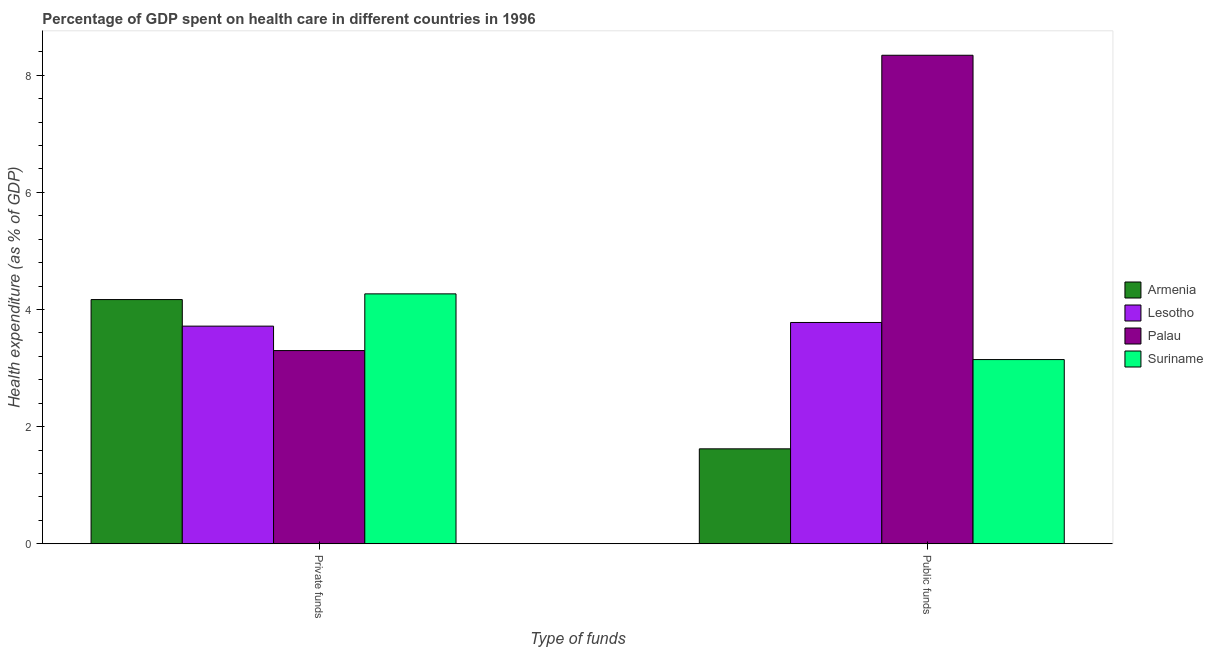How many different coloured bars are there?
Your answer should be compact. 4. How many bars are there on the 1st tick from the right?
Offer a very short reply. 4. What is the label of the 1st group of bars from the left?
Give a very brief answer. Private funds. What is the amount of private funds spent in healthcare in Suriname?
Provide a short and direct response. 4.27. Across all countries, what is the maximum amount of public funds spent in healthcare?
Give a very brief answer. 8.34. Across all countries, what is the minimum amount of private funds spent in healthcare?
Provide a succinct answer. 3.3. In which country was the amount of private funds spent in healthcare maximum?
Offer a very short reply. Suriname. In which country was the amount of public funds spent in healthcare minimum?
Make the answer very short. Armenia. What is the total amount of public funds spent in healthcare in the graph?
Your response must be concise. 16.89. What is the difference between the amount of private funds spent in healthcare in Lesotho and that in Armenia?
Provide a succinct answer. -0.45. What is the difference between the amount of public funds spent in healthcare in Suriname and the amount of private funds spent in healthcare in Lesotho?
Provide a succinct answer. -0.57. What is the average amount of private funds spent in healthcare per country?
Provide a short and direct response. 3.86. What is the difference between the amount of private funds spent in healthcare and amount of public funds spent in healthcare in Armenia?
Your response must be concise. 2.55. What is the ratio of the amount of private funds spent in healthcare in Lesotho to that in Palau?
Offer a very short reply. 1.13. Is the amount of private funds spent in healthcare in Armenia less than that in Suriname?
Offer a very short reply. Yes. What does the 4th bar from the left in Public funds represents?
Provide a short and direct response. Suriname. What does the 3rd bar from the right in Private funds represents?
Ensure brevity in your answer.  Lesotho. What is the difference between two consecutive major ticks on the Y-axis?
Give a very brief answer. 2. Does the graph contain grids?
Your response must be concise. No. Where does the legend appear in the graph?
Make the answer very short. Center right. How many legend labels are there?
Make the answer very short. 4. What is the title of the graph?
Provide a succinct answer. Percentage of GDP spent on health care in different countries in 1996. Does "Kuwait" appear as one of the legend labels in the graph?
Give a very brief answer. No. What is the label or title of the X-axis?
Offer a terse response. Type of funds. What is the label or title of the Y-axis?
Offer a terse response. Health expenditure (as % of GDP). What is the Health expenditure (as % of GDP) of Armenia in Private funds?
Ensure brevity in your answer.  4.17. What is the Health expenditure (as % of GDP) in Lesotho in Private funds?
Your answer should be very brief. 3.72. What is the Health expenditure (as % of GDP) in Palau in Private funds?
Provide a succinct answer. 3.3. What is the Health expenditure (as % of GDP) in Suriname in Private funds?
Your answer should be compact. 4.27. What is the Health expenditure (as % of GDP) in Armenia in Public funds?
Ensure brevity in your answer.  1.62. What is the Health expenditure (as % of GDP) in Lesotho in Public funds?
Ensure brevity in your answer.  3.78. What is the Health expenditure (as % of GDP) in Palau in Public funds?
Give a very brief answer. 8.34. What is the Health expenditure (as % of GDP) in Suriname in Public funds?
Ensure brevity in your answer.  3.15. Across all Type of funds, what is the maximum Health expenditure (as % of GDP) in Armenia?
Your answer should be compact. 4.17. Across all Type of funds, what is the maximum Health expenditure (as % of GDP) of Lesotho?
Keep it short and to the point. 3.78. Across all Type of funds, what is the maximum Health expenditure (as % of GDP) in Palau?
Offer a terse response. 8.34. Across all Type of funds, what is the maximum Health expenditure (as % of GDP) in Suriname?
Offer a terse response. 4.27. Across all Type of funds, what is the minimum Health expenditure (as % of GDP) of Armenia?
Make the answer very short. 1.62. Across all Type of funds, what is the minimum Health expenditure (as % of GDP) of Lesotho?
Provide a short and direct response. 3.72. Across all Type of funds, what is the minimum Health expenditure (as % of GDP) of Palau?
Provide a short and direct response. 3.3. Across all Type of funds, what is the minimum Health expenditure (as % of GDP) in Suriname?
Make the answer very short. 3.15. What is the total Health expenditure (as % of GDP) of Armenia in the graph?
Your answer should be compact. 5.79. What is the total Health expenditure (as % of GDP) of Lesotho in the graph?
Provide a succinct answer. 7.49. What is the total Health expenditure (as % of GDP) in Palau in the graph?
Ensure brevity in your answer.  11.64. What is the total Health expenditure (as % of GDP) in Suriname in the graph?
Provide a short and direct response. 7.41. What is the difference between the Health expenditure (as % of GDP) in Armenia in Private funds and that in Public funds?
Ensure brevity in your answer.  2.55. What is the difference between the Health expenditure (as % of GDP) of Lesotho in Private funds and that in Public funds?
Offer a terse response. -0.06. What is the difference between the Health expenditure (as % of GDP) of Palau in Private funds and that in Public funds?
Offer a very short reply. -5.04. What is the difference between the Health expenditure (as % of GDP) in Suriname in Private funds and that in Public funds?
Make the answer very short. 1.12. What is the difference between the Health expenditure (as % of GDP) of Armenia in Private funds and the Health expenditure (as % of GDP) of Lesotho in Public funds?
Provide a short and direct response. 0.39. What is the difference between the Health expenditure (as % of GDP) of Armenia in Private funds and the Health expenditure (as % of GDP) of Palau in Public funds?
Your answer should be very brief. -4.17. What is the difference between the Health expenditure (as % of GDP) of Armenia in Private funds and the Health expenditure (as % of GDP) of Suriname in Public funds?
Your answer should be very brief. 1.02. What is the difference between the Health expenditure (as % of GDP) in Lesotho in Private funds and the Health expenditure (as % of GDP) in Palau in Public funds?
Your answer should be very brief. -4.62. What is the difference between the Health expenditure (as % of GDP) of Lesotho in Private funds and the Health expenditure (as % of GDP) of Suriname in Public funds?
Provide a short and direct response. 0.57. What is the difference between the Health expenditure (as % of GDP) in Palau in Private funds and the Health expenditure (as % of GDP) in Suriname in Public funds?
Make the answer very short. 0.15. What is the average Health expenditure (as % of GDP) in Armenia per Type of funds?
Keep it short and to the point. 2.9. What is the average Health expenditure (as % of GDP) in Lesotho per Type of funds?
Offer a very short reply. 3.75. What is the average Health expenditure (as % of GDP) of Palau per Type of funds?
Give a very brief answer. 5.82. What is the average Health expenditure (as % of GDP) of Suriname per Type of funds?
Provide a succinct answer. 3.71. What is the difference between the Health expenditure (as % of GDP) in Armenia and Health expenditure (as % of GDP) in Lesotho in Private funds?
Ensure brevity in your answer.  0.45. What is the difference between the Health expenditure (as % of GDP) in Armenia and Health expenditure (as % of GDP) in Palau in Private funds?
Offer a terse response. 0.87. What is the difference between the Health expenditure (as % of GDP) of Armenia and Health expenditure (as % of GDP) of Suriname in Private funds?
Make the answer very short. -0.1. What is the difference between the Health expenditure (as % of GDP) in Lesotho and Health expenditure (as % of GDP) in Palau in Private funds?
Ensure brevity in your answer.  0.42. What is the difference between the Health expenditure (as % of GDP) of Lesotho and Health expenditure (as % of GDP) of Suriname in Private funds?
Offer a terse response. -0.55. What is the difference between the Health expenditure (as % of GDP) in Palau and Health expenditure (as % of GDP) in Suriname in Private funds?
Ensure brevity in your answer.  -0.97. What is the difference between the Health expenditure (as % of GDP) in Armenia and Health expenditure (as % of GDP) in Lesotho in Public funds?
Offer a very short reply. -2.16. What is the difference between the Health expenditure (as % of GDP) in Armenia and Health expenditure (as % of GDP) in Palau in Public funds?
Keep it short and to the point. -6.72. What is the difference between the Health expenditure (as % of GDP) in Armenia and Health expenditure (as % of GDP) in Suriname in Public funds?
Give a very brief answer. -1.52. What is the difference between the Health expenditure (as % of GDP) of Lesotho and Health expenditure (as % of GDP) of Palau in Public funds?
Offer a terse response. -4.56. What is the difference between the Health expenditure (as % of GDP) of Lesotho and Health expenditure (as % of GDP) of Suriname in Public funds?
Your answer should be very brief. 0.63. What is the difference between the Health expenditure (as % of GDP) of Palau and Health expenditure (as % of GDP) of Suriname in Public funds?
Provide a succinct answer. 5.2. What is the ratio of the Health expenditure (as % of GDP) of Armenia in Private funds to that in Public funds?
Provide a succinct answer. 2.57. What is the ratio of the Health expenditure (as % of GDP) of Lesotho in Private funds to that in Public funds?
Give a very brief answer. 0.98. What is the ratio of the Health expenditure (as % of GDP) of Palau in Private funds to that in Public funds?
Provide a short and direct response. 0.4. What is the ratio of the Health expenditure (as % of GDP) of Suriname in Private funds to that in Public funds?
Provide a succinct answer. 1.36. What is the difference between the highest and the second highest Health expenditure (as % of GDP) in Armenia?
Your answer should be compact. 2.55. What is the difference between the highest and the second highest Health expenditure (as % of GDP) in Lesotho?
Give a very brief answer. 0.06. What is the difference between the highest and the second highest Health expenditure (as % of GDP) in Palau?
Give a very brief answer. 5.04. What is the difference between the highest and the second highest Health expenditure (as % of GDP) in Suriname?
Give a very brief answer. 1.12. What is the difference between the highest and the lowest Health expenditure (as % of GDP) in Armenia?
Provide a succinct answer. 2.55. What is the difference between the highest and the lowest Health expenditure (as % of GDP) of Lesotho?
Offer a very short reply. 0.06. What is the difference between the highest and the lowest Health expenditure (as % of GDP) in Palau?
Offer a terse response. 5.04. What is the difference between the highest and the lowest Health expenditure (as % of GDP) in Suriname?
Provide a short and direct response. 1.12. 